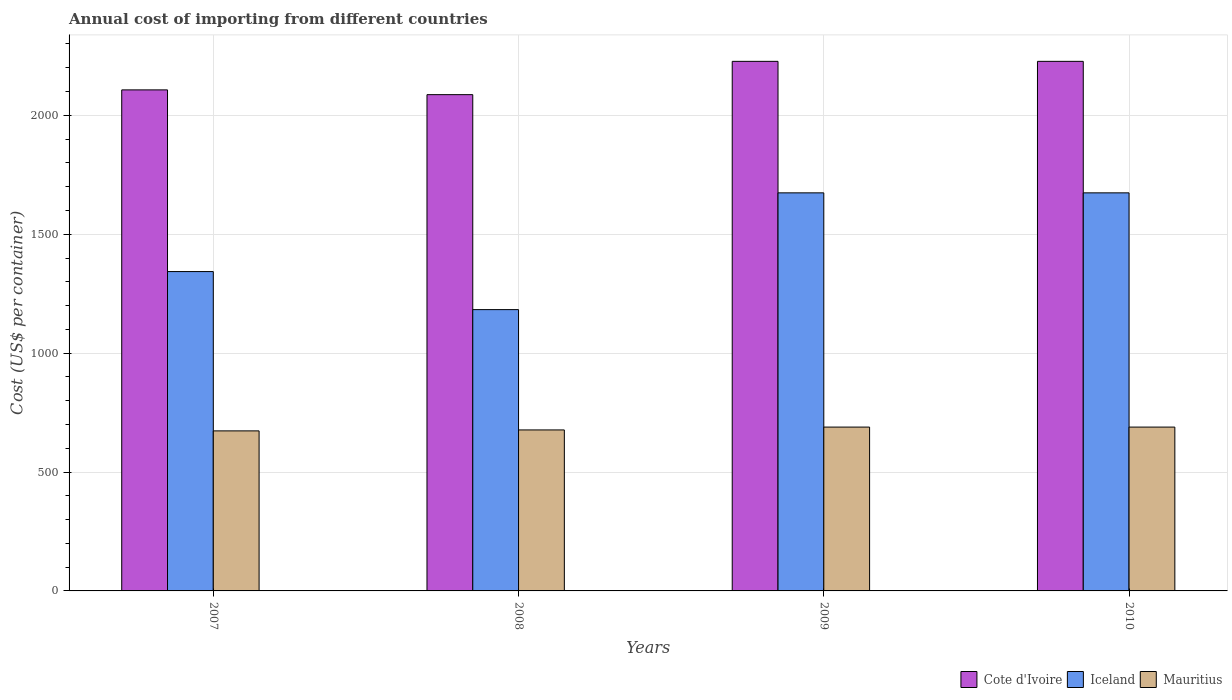How many groups of bars are there?
Make the answer very short. 4. Are the number of bars per tick equal to the number of legend labels?
Make the answer very short. Yes. Are the number of bars on each tick of the X-axis equal?
Your response must be concise. Yes. In how many cases, is the number of bars for a given year not equal to the number of legend labels?
Give a very brief answer. 0. What is the total annual cost of importing in Cote d'Ivoire in 2008?
Offer a very short reply. 2087. Across all years, what is the maximum total annual cost of importing in Mauritius?
Provide a short and direct response. 689. Across all years, what is the minimum total annual cost of importing in Mauritius?
Offer a terse response. 673. In which year was the total annual cost of importing in Cote d'Ivoire maximum?
Your response must be concise. 2009. What is the total total annual cost of importing in Cote d'Ivoire in the graph?
Provide a succinct answer. 8648. What is the difference between the total annual cost of importing in Cote d'Ivoire in 2008 and that in 2009?
Your answer should be very brief. -140. What is the difference between the total annual cost of importing in Mauritius in 2007 and the total annual cost of importing in Cote d'Ivoire in 2010?
Keep it short and to the point. -1554. What is the average total annual cost of importing in Iceland per year?
Keep it short and to the point. 1468.5. In the year 2008, what is the difference between the total annual cost of importing in Mauritius and total annual cost of importing in Cote d'Ivoire?
Provide a succinct answer. -1410. In how many years, is the total annual cost of importing in Mauritius greater than 1300 US$?
Provide a succinct answer. 0. What is the ratio of the total annual cost of importing in Mauritius in 2008 to that in 2009?
Provide a short and direct response. 0.98. Is the total annual cost of importing in Iceland in 2008 less than that in 2009?
Keep it short and to the point. Yes. What is the difference between the highest and the lowest total annual cost of importing in Cote d'Ivoire?
Your answer should be compact. 140. In how many years, is the total annual cost of importing in Cote d'Ivoire greater than the average total annual cost of importing in Cote d'Ivoire taken over all years?
Your response must be concise. 2. What does the 3rd bar from the left in 2010 represents?
Ensure brevity in your answer.  Mauritius. What does the 3rd bar from the right in 2010 represents?
Make the answer very short. Cote d'Ivoire. Are all the bars in the graph horizontal?
Provide a short and direct response. No. How many years are there in the graph?
Your answer should be very brief. 4. Does the graph contain any zero values?
Offer a terse response. No. What is the title of the graph?
Provide a succinct answer. Annual cost of importing from different countries. What is the label or title of the Y-axis?
Provide a succinct answer. Cost (US$ per container). What is the Cost (US$ per container) in Cote d'Ivoire in 2007?
Offer a very short reply. 2107. What is the Cost (US$ per container) in Iceland in 2007?
Provide a succinct answer. 1343. What is the Cost (US$ per container) of Mauritius in 2007?
Keep it short and to the point. 673. What is the Cost (US$ per container) in Cote d'Ivoire in 2008?
Your answer should be compact. 2087. What is the Cost (US$ per container) of Iceland in 2008?
Make the answer very short. 1183. What is the Cost (US$ per container) in Mauritius in 2008?
Keep it short and to the point. 677. What is the Cost (US$ per container) in Cote d'Ivoire in 2009?
Your response must be concise. 2227. What is the Cost (US$ per container) of Iceland in 2009?
Offer a very short reply. 1674. What is the Cost (US$ per container) in Mauritius in 2009?
Make the answer very short. 689. What is the Cost (US$ per container) of Cote d'Ivoire in 2010?
Provide a short and direct response. 2227. What is the Cost (US$ per container) in Iceland in 2010?
Give a very brief answer. 1674. What is the Cost (US$ per container) of Mauritius in 2010?
Provide a succinct answer. 689. Across all years, what is the maximum Cost (US$ per container) of Cote d'Ivoire?
Your answer should be very brief. 2227. Across all years, what is the maximum Cost (US$ per container) in Iceland?
Ensure brevity in your answer.  1674. Across all years, what is the maximum Cost (US$ per container) in Mauritius?
Provide a succinct answer. 689. Across all years, what is the minimum Cost (US$ per container) in Cote d'Ivoire?
Provide a short and direct response. 2087. Across all years, what is the minimum Cost (US$ per container) in Iceland?
Provide a succinct answer. 1183. Across all years, what is the minimum Cost (US$ per container) in Mauritius?
Make the answer very short. 673. What is the total Cost (US$ per container) in Cote d'Ivoire in the graph?
Your answer should be compact. 8648. What is the total Cost (US$ per container) of Iceland in the graph?
Your response must be concise. 5874. What is the total Cost (US$ per container) of Mauritius in the graph?
Your answer should be compact. 2728. What is the difference between the Cost (US$ per container) of Iceland in 2007 and that in 2008?
Make the answer very short. 160. What is the difference between the Cost (US$ per container) in Cote d'Ivoire in 2007 and that in 2009?
Your answer should be very brief. -120. What is the difference between the Cost (US$ per container) of Iceland in 2007 and that in 2009?
Give a very brief answer. -331. What is the difference between the Cost (US$ per container) in Mauritius in 2007 and that in 2009?
Ensure brevity in your answer.  -16. What is the difference between the Cost (US$ per container) in Cote d'Ivoire in 2007 and that in 2010?
Provide a short and direct response. -120. What is the difference between the Cost (US$ per container) of Iceland in 2007 and that in 2010?
Keep it short and to the point. -331. What is the difference between the Cost (US$ per container) in Cote d'Ivoire in 2008 and that in 2009?
Make the answer very short. -140. What is the difference between the Cost (US$ per container) of Iceland in 2008 and that in 2009?
Provide a succinct answer. -491. What is the difference between the Cost (US$ per container) in Cote d'Ivoire in 2008 and that in 2010?
Keep it short and to the point. -140. What is the difference between the Cost (US$ per container) in Iceland in 2008 and that in 2010?
Keep it short and to the point. -491. What is the difference between the Cost (US$ per container) in Mauritius in 2008 and that in 2010?
Provide a succinct answer. -12. What is the difference between the Cost (US$ per container) of Cote d'Ivoire in 2009 and that in 2010?
Offer a very short reply. 0. What is the difference between the Cost (US$ per container) in Iceland in 2009 and that in 2010?
Keep it short and to the point. 0. What is the difference between the Cost (US$ per container) of Mauritius in 2009 and that in 2010?
Provide a short and direct response. 0. What is the difference between the Cost (US$ per container) in Cote d'Ivoire in 2007 and the Cost (US$ per container) in Iceland in 2008?
Make the answer very short. 924. What is the difference between the Cost (US$ per container) of Cote d'Ivoire in 2007 and the Cost (US$ per container) of Mauritius in 2008?
Your answer should be compact. 1430. What is the difference between the Cost (US$ per container) of Iceland in 2007 and the Cost (US$ per container) of Mauritius in 2008?
Make the answer very short. 666. What is the difference between the Cost (US$ per container) in Cote d'Ivoire in 2007 and the Cost (US$ per container) in Iceland in 2009?
Give a very brief answer. 433. What is the difference between the Cost (US$ per container) in Cote d'Ivoire in 2007 and the Cost (US$ per container) in Mauritius in 2009?
Your response must be concise. 1418. What is the difference between the Cost (US$ per container) of Iceland in 2007 and the Cost (US$ per container) of Mauritius in 2009?
Your answer should be very brief. 654. What is the difference between the Cost (US$ per container) of Cote d'Ivoire in 2007 and the Cost (US$ per container) of Iceland in 2010?
Offer a terse response. 433. What is the difference between the Cost (US$ per container) of Cote d'Ivoire in 2007 and the Cost (US$ per container) of Mauritius in 2010?
Keep it short and to the point. 1418. What is the difference between the Cost (US$ per container) of Iceland in 2007 and the Cost (US$ per container) of Mauritius in 2010?
Your answer should be very brief. 654. What is the difference between the Cost (US$ per container) of Cote d'Ivoire in 2008 and the Cost (US$ per container) of Iceland in 2009?
Ensure brevity in your answer.  413. What is the difference between the Cost (US$ per container) of Cote d'Ivoire in 2008 and the Cost (US$ per container) of Mauritius in 2009?
Keep it short and to the point. 1398. What is the difference between the Cost (US$ per container) in Iceland in 2008 and the Cost (US$ per container) in Mauritius in 2009?
Keep it short and to the point. 494. What is the difference between the Cost (US$ per container) in Cote d'Ivoire in 2008 and the Cost (US$ per container) in Iceland in 2010?
Provide a short and direct response. 413. What is the difference between the Cost (US$ per container) in Cote d'Ivoire in 2008 and the Cost (US$ per container) in Mauritius in 2010?
Your answer should be very brief. 1398. What is the difference between the Cost (US$ per container) of Iceland in 2008 and the Cost (US$ per container) of Mauritius in 2010?
Provide a short and direct response. 494. What is the difference between the Cost (US$ per container) in Cote d'Ivoire in 2009 and the Cost (US$ per container) in Iceland in 2010?
Make the answer very short. 553. What is the difference between the Cost (US$ per container) of Cote d'Ivoire in 2009 and the Cost (US$ per container) of Mauritius in 2010?
Ensure brevity in your answer.  1538. What is the difference between the Cost (US$ per container) in Iceland in 2009 and the Cost (US$ per container) in Mauritius in 2010?
Provide a succinct answer. 985. What is the average Cost (US$ per container) of Cote d'Ivoire per year?
Offer a terse response. 2162. What is the average Cost (US$ per container) in Iceland per year?
Your answer should be compact. 1468.5. What is the average Cost (US$ per container) in Mauritius per year?
Give a very brief answer. 682. In the year 2007, what is the difference between the Cost (US$ per container) of Cote d'Ivoire and Cost (US$ per container) of Iceland?
Give a very brief answer. 764. In the year 2007, what is the difference between the Cost (US$ per container) in Cote d'Ivoire and Cost (US$ per container) in Mauritius?
Your answer should be compact. 1434. In the year 2007, what is the difference between the Cost (US$ per container) of Iceland and Cost (US$ per container) of Mauritius?
Your answer should be very brief. 670. In the year 2008, what is the difference between the Cost (US$ per container) in Cote d'Ivoire and Cost (US$ per container) in Iceland?
Your answer should be compact. 904. In the year 2008, what is the difference between the Cost (US$ per container) of Cote d'Ivoire and Cost (US$ per container) of Mauritius?
Offer a very short reply. 1410. In the year 2008, what is the difference between the Cost (US$ per container) of Iceland and Cost (US$ per container) of Mauritius?
Provide a short and direct response. 506. In the year 2009, what is the difference between the Cost (US$ per container) of Cote d'Ivoire and Cost (US$ per container) of Iceland?
Ensure brevity in your answer.  553. In the year 2009, what is the difference between the Cost (US$ per container) of Cote d'Ivoire and Cost (US$ per container) of Mauritius?
Offer a very short reply. 1538. In the year 2009, what is the difference between the Cost (US$ per container) in Iceland and Cost (US$ per container) in Mauritius?
Give a very brief answer. 985. In the year 2010, what is the difference between the Cost (US$ per container) of Cote d'Ivoire and Cost (US$ per container) of Iceland?
Your answer should be very brief. 553. In the year 2010, what is the difference between the Cost (US$ per container) of Cote d'Ivoire and Cost (US$ per container) of Mauritius?
Your response must be concise. 1538. In the year 2010, what is the difference between the Cost (US$ per container) in Iceland and Cost (US$ per container) in Mauritius?
Your response must be concise. 985. What is the ratio of the Cost (US$ per container) in Cote d'Ivoire in 2007 to that in 2008?
Ensure brevity in your answer.  1.01. What is the ratio of the Cost (US$ per container) of Iceland in 2007 to that in 2008?
Your answer should be compact. 1.14. What is the ratio of the Cost (US$ per container) in Cote d'Ivoire in 2007 to that in 2009?
Your answer should be very brief. 0.95. What is the ratio of the Cost (US$ per container) in Iceland in 2007 to that in 2009?
Your response must be concise. 0.8. What is the ratio of the Cost (US$ per container) of Mauritius in 2007 to that in 2009?
Make the answer very short. 0.98. What is the ratio of the Cost (US$ per container) of Cote d'Ivoire in 2007 to that in 2010?
Give a very brief answer. 0.95. What is the ratio of the Cost (US$ per container) in Iceland in 2007 to that in 2010?
Give a very brief answer. 0.8. What is the ratio of the Cost (US$ per container) in Mauritius in 2007 to that in 2010?
Your answer should be very brief. 0.98. What is the ratio of the Cost (US$ per container) in Cote d'Ivoire in 2008 to that in 2009?
Your answer should be very brief. 0.94. What is the ratio of the Cost (US$ per container) of Iceland in 2008 to that in 2009?
Give a very brief answer. 0.71. What is the ratio of the Cost (US$ per container) of Mauritius in 2008 to that in 2009?
Make the answer very short. 0.98. What is the ratio of the Cost (US$ per container) of Cote d'Ivoire in 2008 to that in 2010?
Your answer should be very brief. 0.94. What is the ratio of the Cost (US$ per container) of Iceland in 2008 to that in 2010?
Give a very brief answer. 0.71. What is the ratio of the Cost (US$ per container) in Mauritius in 2008 to that in 2010?
Provide a succinct answer. 0.98. What is the ratio of the Cost (US$ per container) of Cote d'Ivoire in 2009 to that in 2010?
Provide a succinct answer. 1. What is the ratio of the Cost (US$ per container) in Iceland in 2009 to that in 2010?
Provide a succinct answer. 1. What is the difference between the highest and the second highest Cost (US$ per container) in Cote d'Ivoire?
Your answer should be very brief. 0. What is the difference between the highest and the second highest Cost (US$ per container) in Iceland?
Offer a terse response. 0. What is the difference between the highest and the lowest Cost (US$ per container) of Cote d'Ivoire?
Your answer should be compact. 140. What is the difference between the highest and the lowest Cost (US$ per container) of Iceland?
Your answer should be compact. 491. What is the difference between the highest and the lowest Cost (US$ per container) of Mauritius?
Your answer should be very brief. 16. 